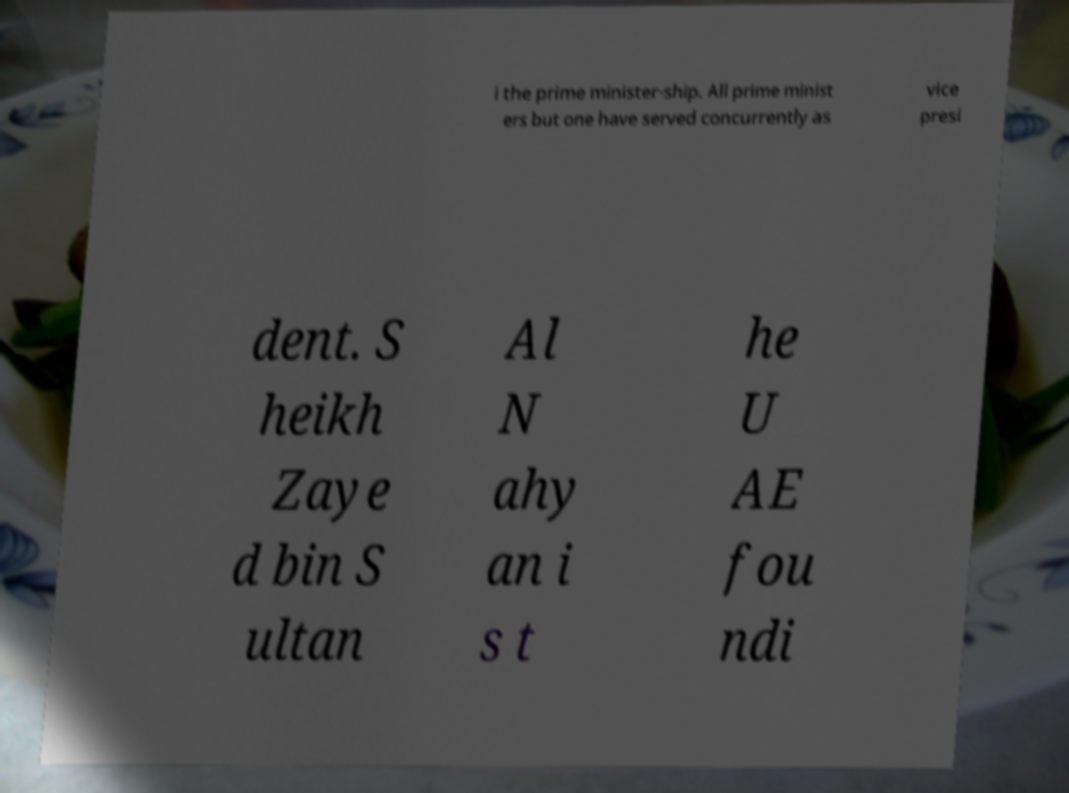Could you assist in decoding the text presented in this image and type it out clearly? i the prime minister-ship. All prime minist ers but one have served concurrently as vice presi dent. S heikh Zaye d bin S ultan Al N ahy an i s t he U AE fou ndi 